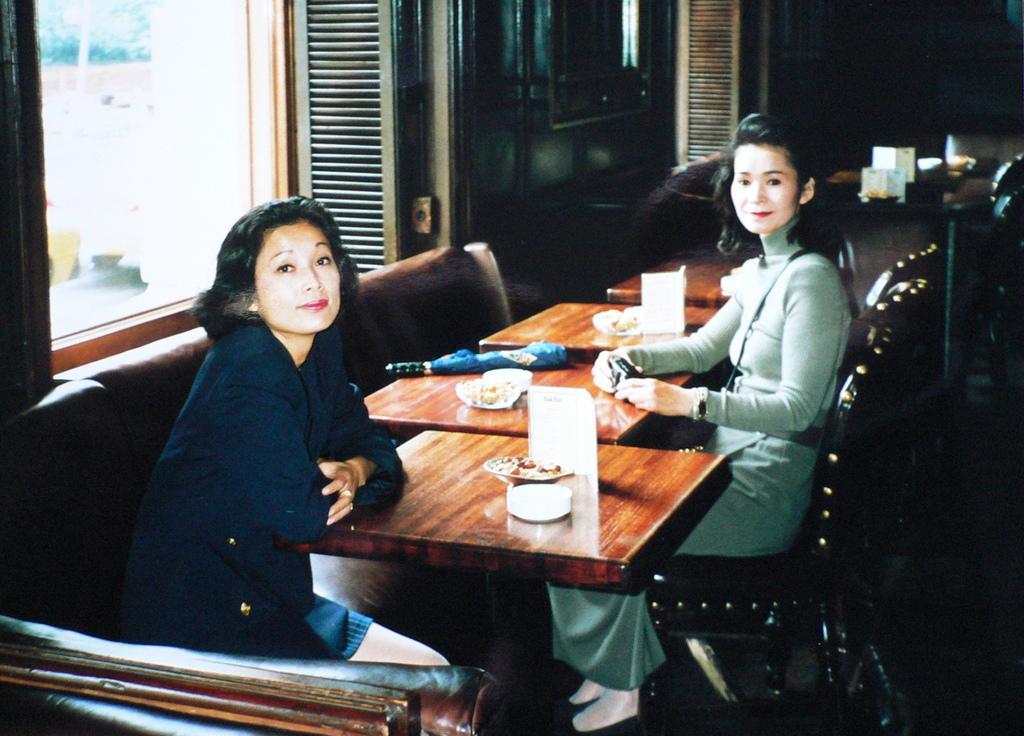How would you summarize this image in a sentence or two? There are two women sitting here in the chair in front of a table. There is some food on the table in front of them. We can observe a window in the background and a wall here. 